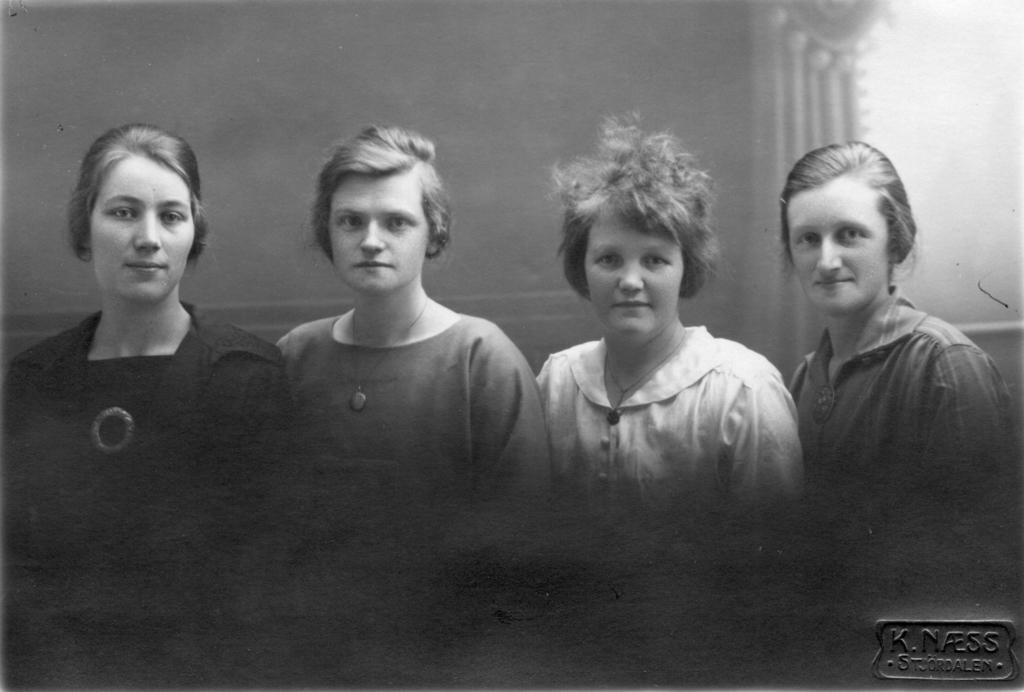How many people are present in the image? There are four persons in the image. What else can be seen in the image besides the people? There is text and a building visible in the image. What type of news can be seen on the sidewalk in the image? There is no sidewalk or news present in the image. 